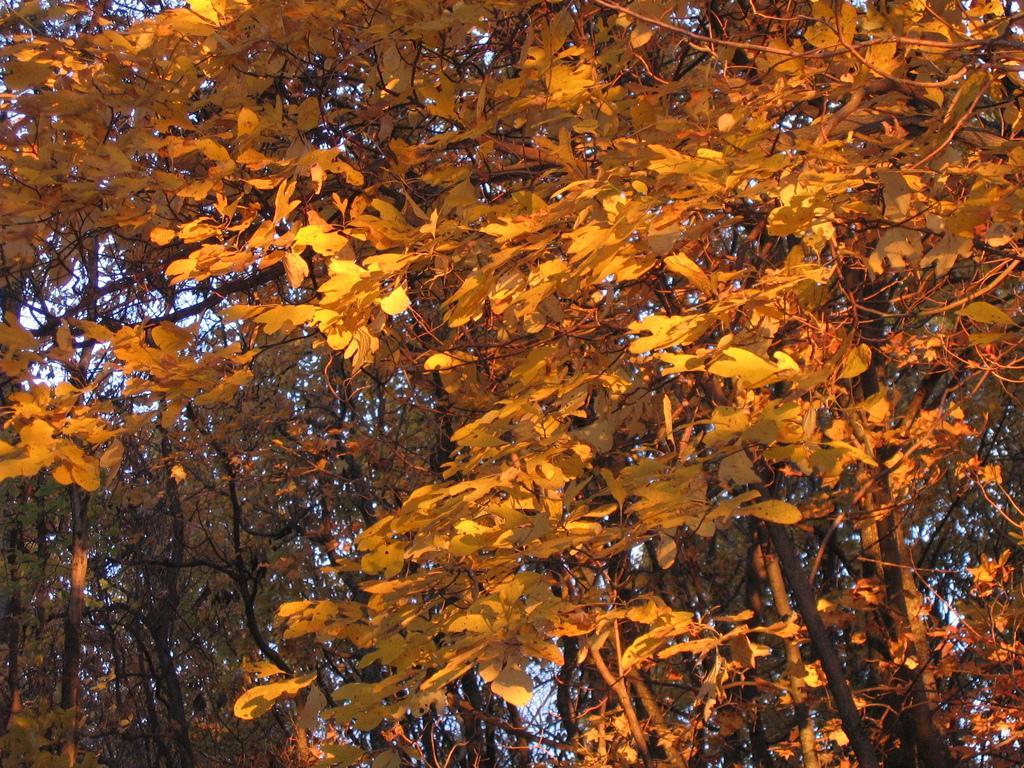How would you summarize this image in a sentence or two? In this image we can see trees. In the background there is sky. 